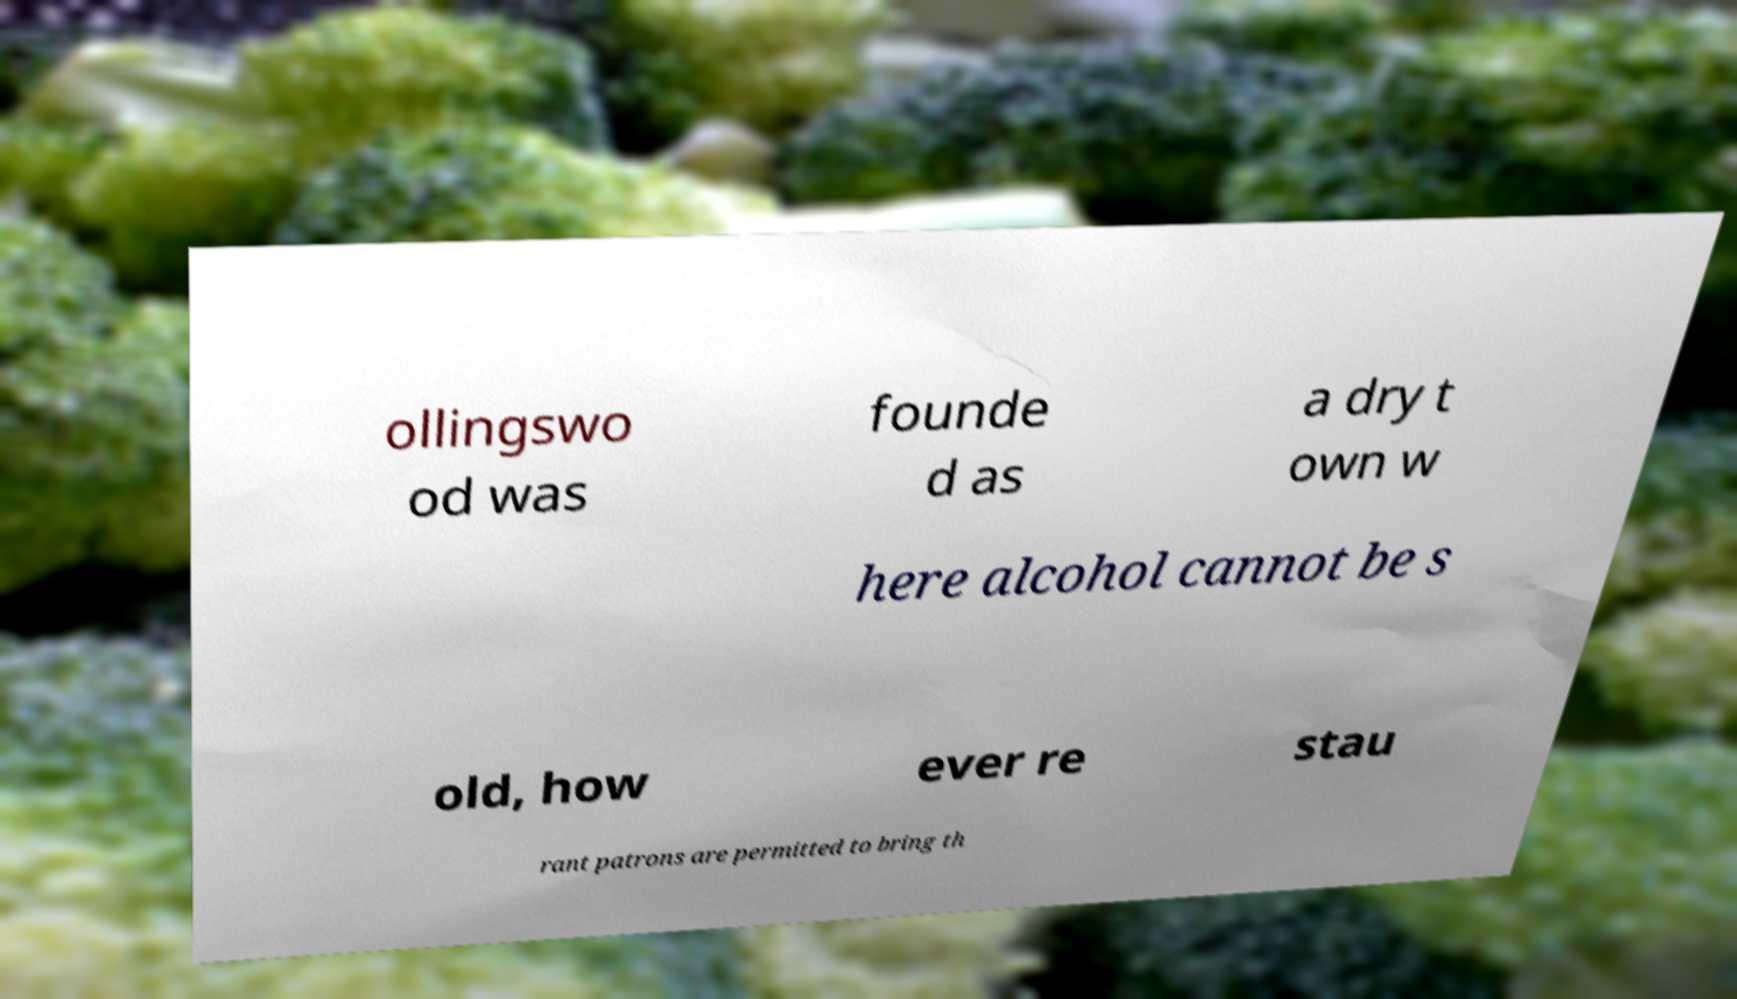Could you assist in decoding the text presented in this image and type it out clearly? ollingswo od was founde d as a dry t own w here alcohol cannot be s old, how ever re stau rant patrons are permitted to bring th 